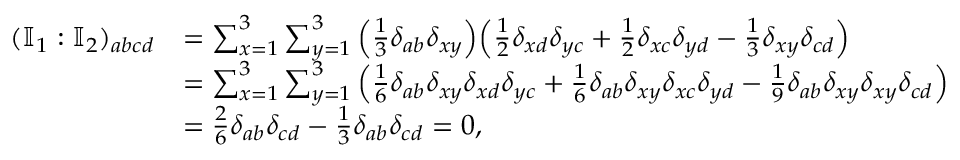Convert formula to latex. <formula><loc_0><loc_0><loc_500><loc_500>\begin{array} { r l } { ( \mathbb { I } _ { 1 } \colon \mathbb { I } _ { 2 } ) _ { a b c d } } & { = \sum _ { x = 1 } ^ { 3 } \sum _ { y = 1 } ^ { 3 } \left ( \frac { 1 } { 3 } \delta _ { a b } \delta _ { x y } \right ) \left ( \frac { 1 } { 2 } \delta _ { x d } \delta _ { y c } + \frac { 1 } { 2 } \delta _ { x c } \delta _ { y d } - \frac { 1 } { 3 } \delta _ { x y } \delta _ { c d } \right ) } \\ & { = \sum _ { x = 1 } ^ { 3 } \sum _ { y = 1 } ^ { 3 } \left ( \frac { 1 } { 6 } \delta _ { a b } \delta _ { x y } \delta _ { x d } \delta _ { y c } + \frac { 1 } { 6 } \delta _ { a b } \delta _ { x y } \delta _ { x c } \delta _ { y d } - \frac { 1 } { 9 } \delta _ { a b } \delta _ { x y } \delta _ { x y } \delta _ { c d } \right ) } \\ & { = \frac { 2 } { 6 } \delta _ { a b } \delta _ { c d } - \frac { 1 } { 3 } \delta _ { a b } \delta _ { c d } = 0 , } \end{array}</formula> 